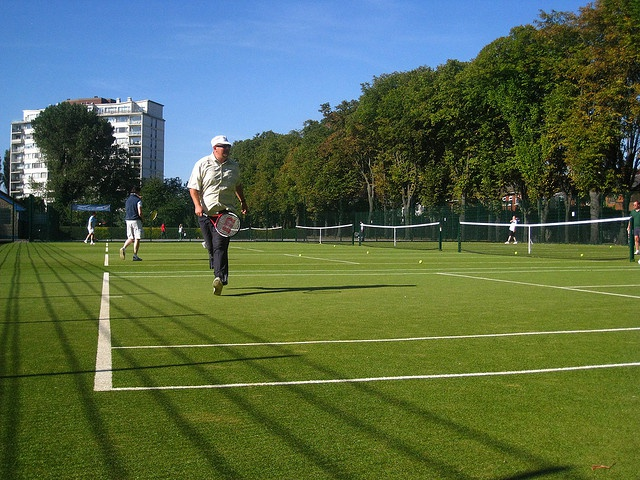Describe the objects in this image and their specific colors. I can see people in gray, black, white, and darkgreen tones, people in gray, black, white, and darkblue tones, tennis racket in gray, black, maroon, and darkgray tones, people in gray, black, teal, and darkgreen tones, and people in gray, white, black, and darkgray tones in this image. 